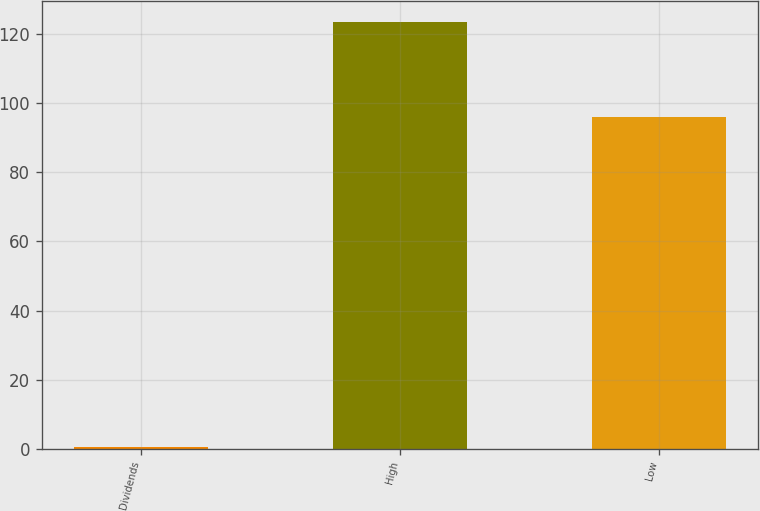Convert chart. <chart><loc_0><loc_0><loc_500><loc_500><bar_chart><fcel>Dividends<fcel>High<fcel>Low<nl><fcel>0.5<fcel>123.61<fcel>96.17<nl></chart> 